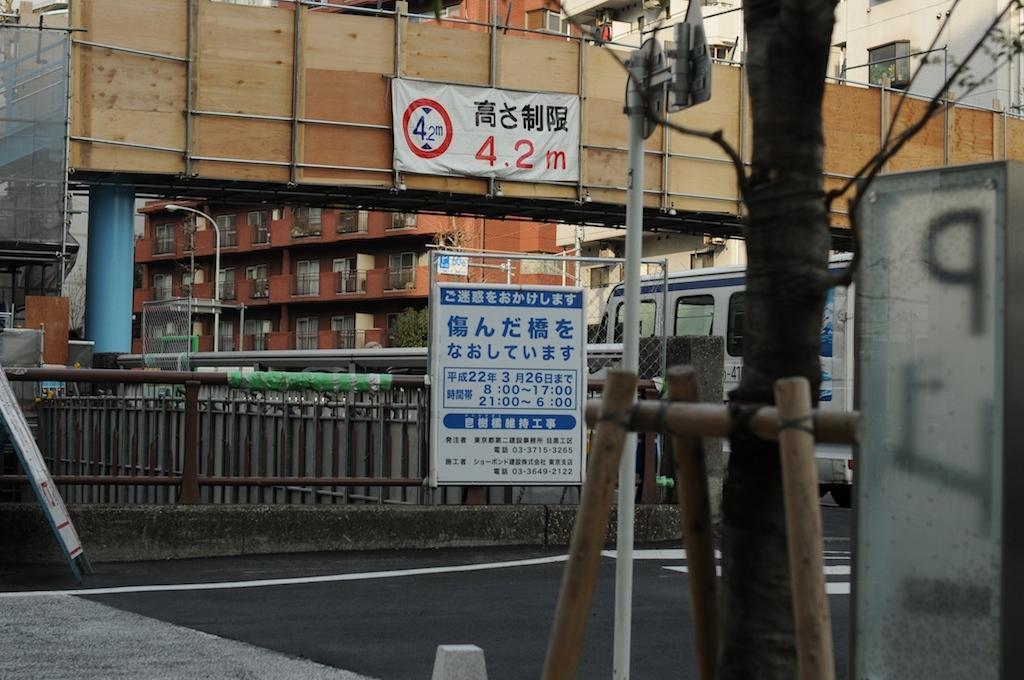How would you summarize this image in a sentence or two? In the center of the image we can see sign board with some text on it, a banner, group of poles and a barricade. In the foreground we can see poles and tree. In the background, we can see a group of buildings with windows ,a train and light poles. 